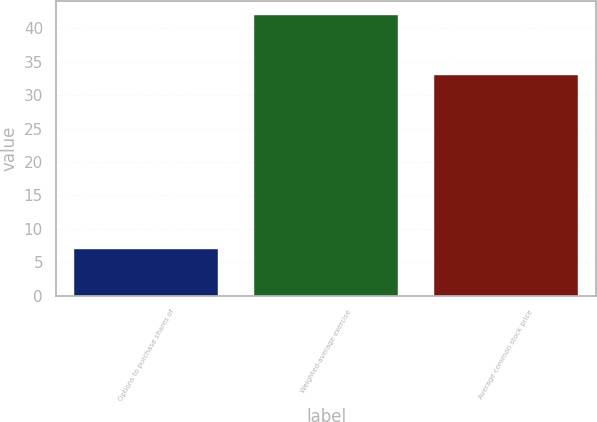Convert chart to OTSL. <chart><loc_0><loc_0><loc_500><loc_500><bar_chart><fcel>Options to purchase shares of<fcel>Weighted-average exercise<fcel>Average common stock price<nl><fcel>7<fcel>42<fcel>33<nl></chart> 